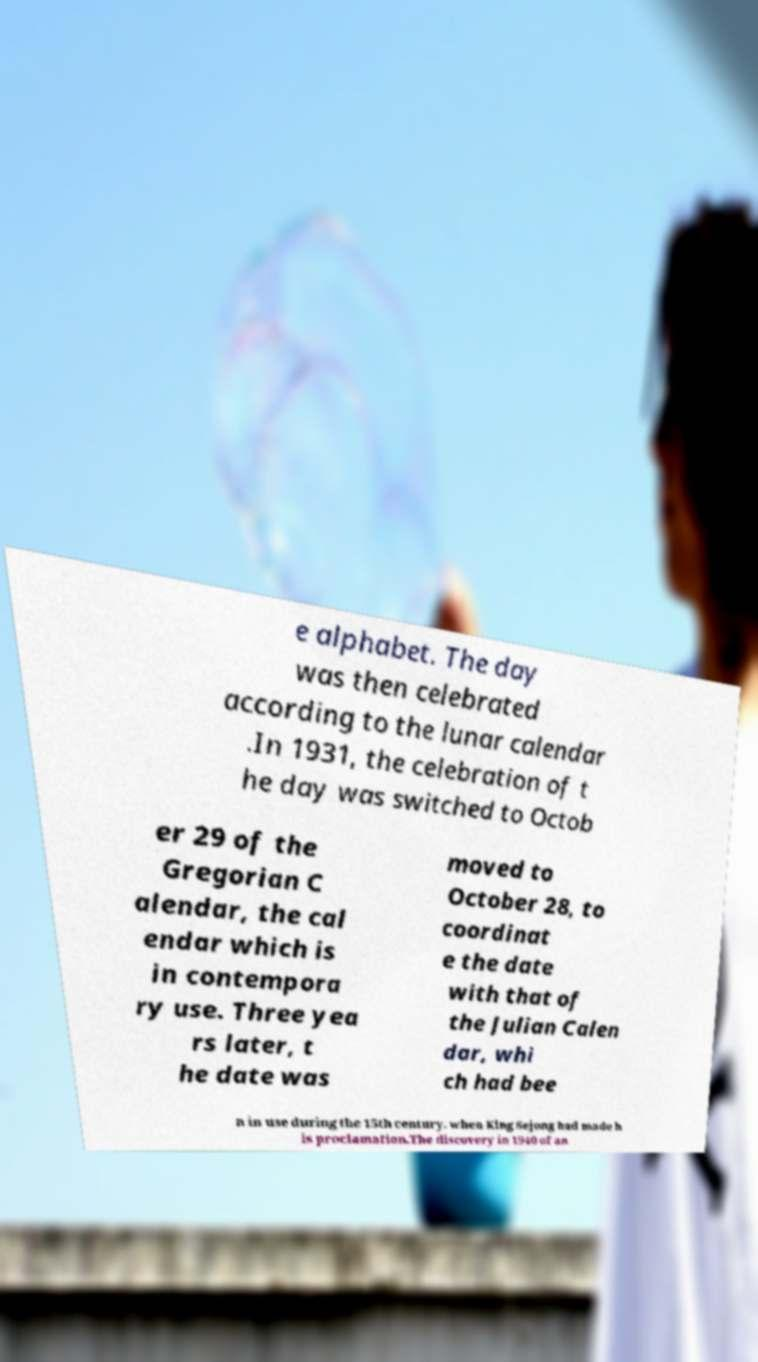Can you read and provide the text displayed in the image?This photo seems to have some interesting text. Can you extract and type it out for me? e alphabet. The day was then celebrated according to the lunar calendar .In 1931, the celebration of t he day was switched to Octob er 29 of the Gregorian C alendar, the cal endar which is in contempora ry use. Three yea rs later, t he date was moved to October 28, to coordinat e the date with that of the Julian Calen dar, whi ch had bee n in use during the 15th century, when King Sejong had made h is proclamation.The discovery in 1940 of an 